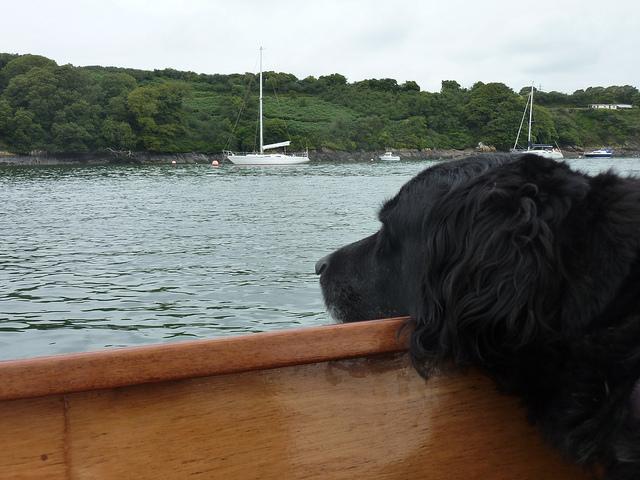What is causing the dog to rest his head on the side of the boat?
Choose the correct response and explain in the format: 'Answer: answer
Rationale: rationale.'
Options: Exhaustion, laziness, command, boredom. Answer: boredom.
Rationale: He's relaxing and looking at where he'd like to be instead 